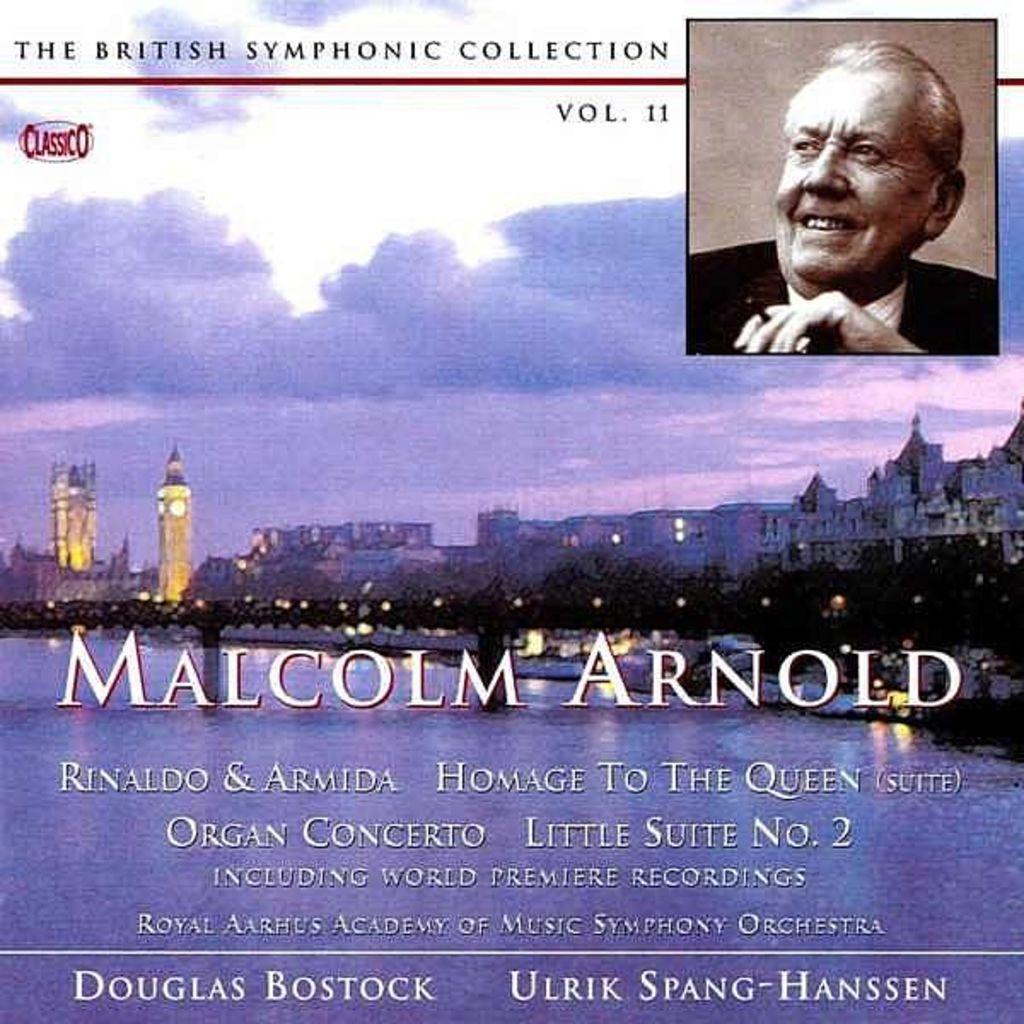Can you describe this image briefly? In this picture I can see there is a picture of a man here on the top right and he is smiling and there is a river, a bridge and there are few buildings in the backdrop and there are trees and the sky is clear. There is something written here at the bottom of the image. 